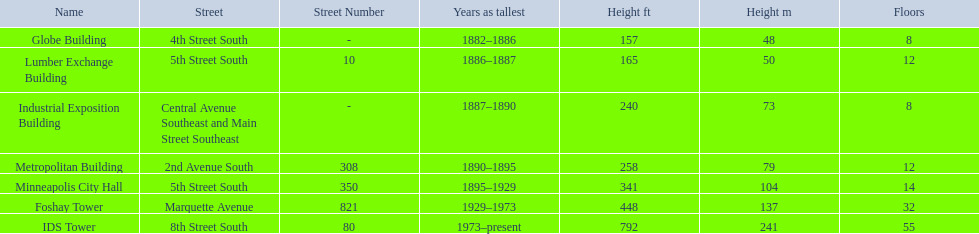How tall is the metropolitan building? 258 (79). How tall is the lumber exchange building? 165 (50). Is the metropolitan or lumber exchange building taller? Metropolitan Building. 